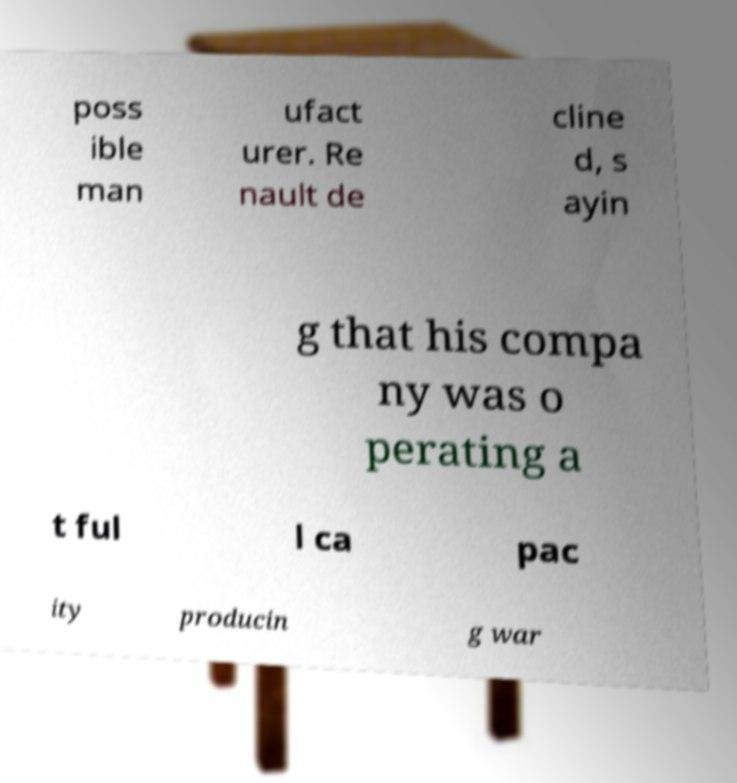For documentation purposes, I need the text within this image transcribed. Could you provide that? poss ible man ufact urer. Re nault de cline d, s ayin g that his compa ny was o perating a t ful l ca pac ity producin g war 